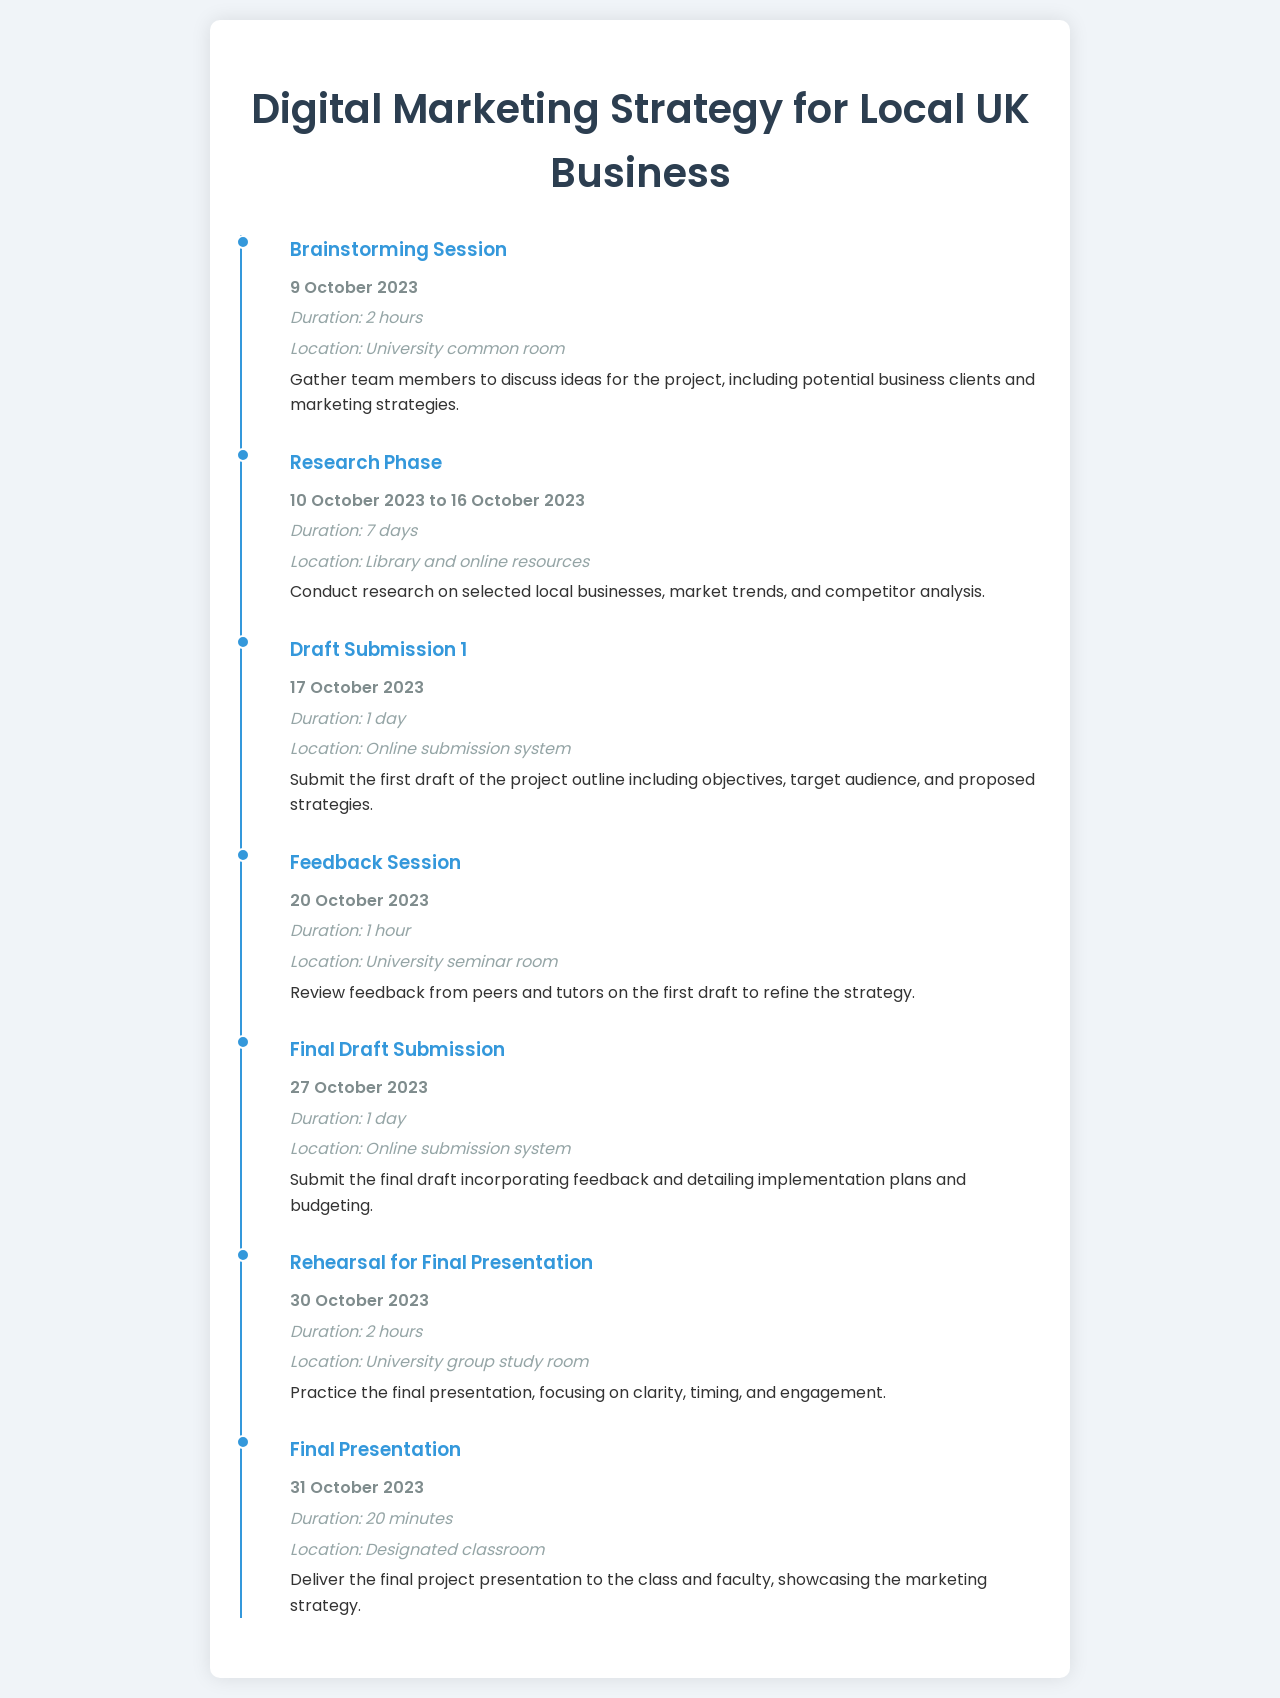What is the date of the brainstorming session? The date is specified in the document as 9 October 2023.
Answer: 9 October 2023 What is the duration of the research phase? The duration is indicated as 7 days from 10 October 2023 to 16 October 2023.
Answer: 7 days Where is the final presentation taking place? The location is stated as a designated classroom in the document.
Answer: Designated classroom What does the first draft submission include? The document specifies that it includes objectives, target audience, and proposed strategies.
Answer: Objectives, target audience, and proposed strategies How long is the final presentation? The document mentions the duration of the final presentation is 20 minutes.
Answer: 20 minutes When is the final draft submission due? The date for the final draft submission is clearly mentioned as 27 October 2023.
Answer: 27 October 2023 What is the purpose of the feedback session? The document explains that its purpose is to review feedback from peers and tutors on the first draft.
Answer: Review feedback from peers and tutors How long is the rehearsal for the final presentation? The rehearsal duration is reported to be 2 hours in the document.
Answer: 2 hours What type of session is the 9 October event? The document indicates that it is a brainstorming session focused on discussing ideas.
Answer: Brainstorming session 